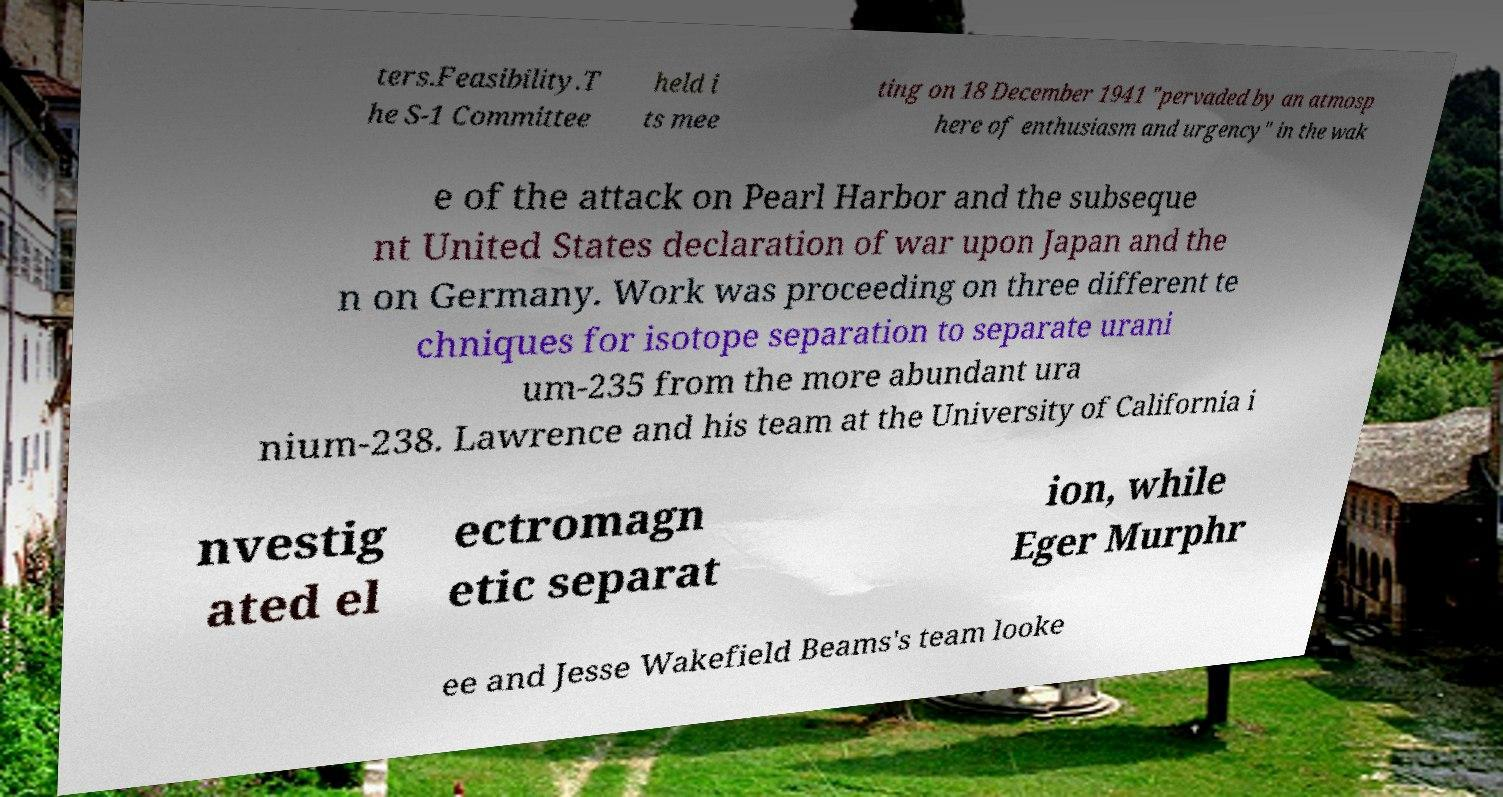What messages or text are displayed in this image? I need them in a readable, typed format. ters.Feasibility.T he S-1 Committee held i ts mee ting on 18 December 1941 "pervaded by an atmosp here of enthusiasm and urgency" in the wak e of the attack on Pearl Harbor and the subseque nt United States declaration of war upon Japan and the n on Germany. Work was proceeding on three different te chniques for isotope separation to separate urani um-235 from the more abundant ura nium-238. Lawrence and his team at the University of California i nvestig ated el ectromagn etic separat ion, while Eger Murphr ee and Jesse Wakefield Beams's team looke 